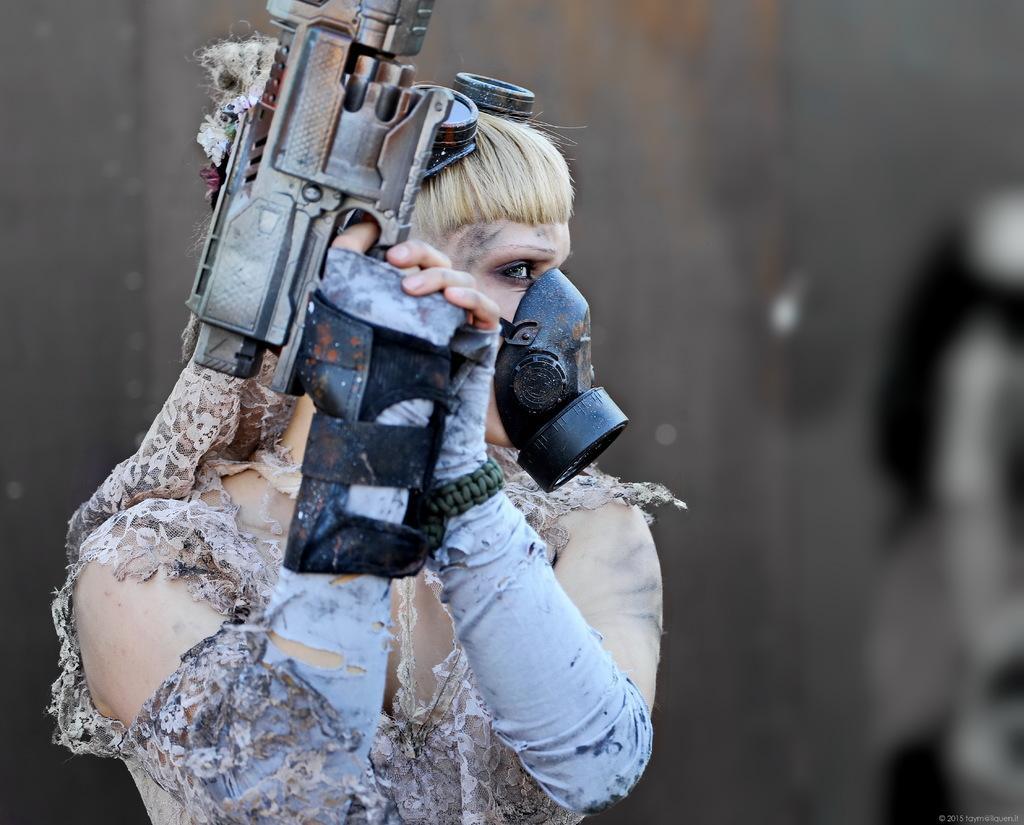Could you give a brief overview of what you see in this image? In this image there is a girl holding the gun by wearing the gloves and a mask. In the background there is a wall. 